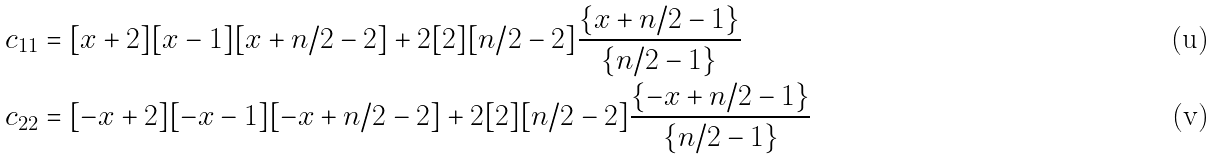Convert formula to latex. <formula><loc_0><loc_0><loc_500><loc_500>c _ { 1 1 } & = [ x + 2 ] [ x - 1 ] [ x + n / 2 - 2 ] + 2 [ 2 ] [ n / 2 - 2 ] \frac { \{ x + n / 2 - 1 \} } { \{ n / 2 - 1 \} } \\ c _ { 2 2 } & = [ - x + 2 ] [ - x - 1 ] [ - x + n / 2 - 2 ] + 2 [ 2 ] [ n / 2 - 2 ] \frac { \{ - x + n / 2 - 1 \} } { \{ n / 2 - 1 \} }</formula> 